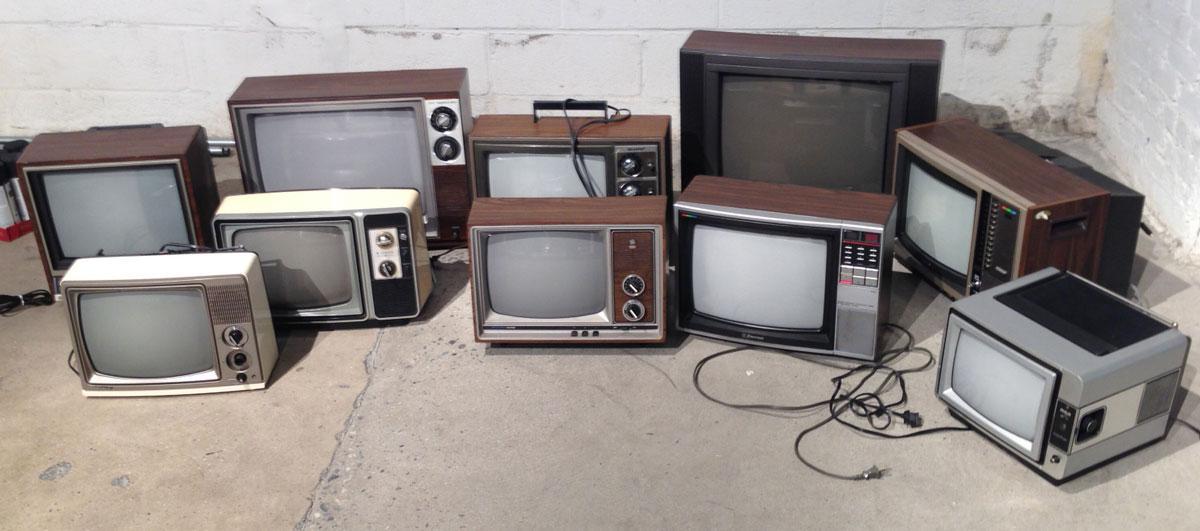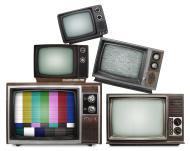The first image is the image on the left, the second image is the image on the right. For the images displayed, is the sentence "The right image contains exactly five old fashioned television sets." factually correct? Answer yes or no. Yes. The first image is the image on the left, the second image is the image on the right. For the images displayed, is the sentence "A stack of old-fashioned TVs includes at least one with a rainbow test pattern and two knobs in a vertical row alongside the screen." factually correct? Answer yes or no. Yes. 